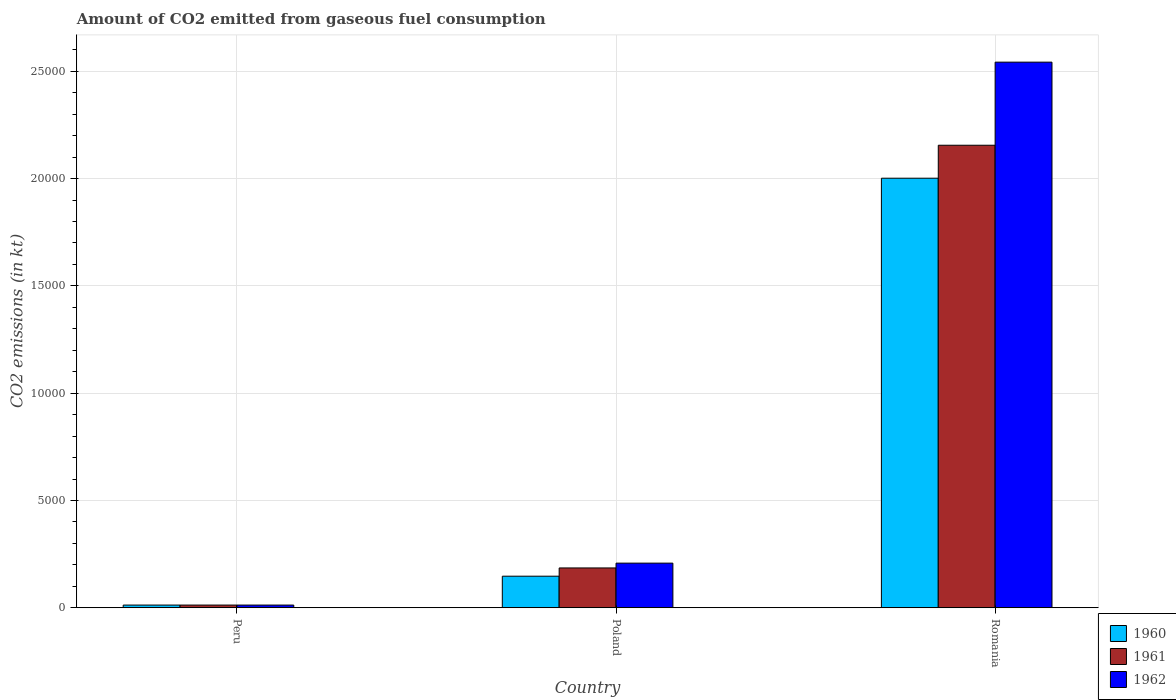How many groups of bars are there?
Make the answer very short. 3. Are the number of bars on each tick of the X-axis equal?
Give a very brief answer. Yes. How many bars are there on the 1st tick from the right?
Ensure brevity in your answer.  3. What is the label of the 2nd group of bars from the left?
Your response must be concise. Poland. What is the amount of CO2 emitted in 1960 in Poland?
Your answer should be compact. 1470.47. Across all countries, what is the maximum amount of CO2 emitted in 1961?
Your answer should be compact. 2.16e+04. Across all countries, what is the minimum amount of CO2 emitted in 1960?
Ensure brevity in your answer.  124.68. In which country was the amount of CO2 emitted in 1961 maximum?
Keep it short and to the point. Romania. What is the total amount of CO2 emitted in 1962 in the graph?
Offer a terse response. 2.76e+04. What is the difference between the amount of CO2 emitted in 1962 in Peru and that in Poland?
Ensure brevity in your answer.  -1954.51. What is the difference between the amount of CO2 emitted in 1961 in Poland and the amount of CO2 emitted in 1962 in Romania?
Ensure brevity in your answer.  -2.36e+04. What is the average amount of CO2 emitted in 1962 per country?
Your answer should be compact. 9210.28. What is the difference between the amount of CO2 emitted of/in 1960 and amount of CO2 emitted of/in 1962 in Poland?
Provide a succinct answer. -608.72. In how many countries, is the amount of CO2 emitted in 1960 greater than 22000 kt?
Provide a short and direct response. 0. What is the ratio of the amount of CO2 emitted in 1961 in Peru to that in Romania?
Ensure brevity in your answer.  0.01. Is the difference between the amount of CO2 emitted in 1960 in Peru and Poland greater than the difference between the amount of CO2 emitted in 1962 in Peru and Poland?
Keep it short and to the point. Yes. What is the difference between the highest and the second highest amount of CO2 emitted in 1960?
Provide a short and direct response. 1.99e+04. What is the difference between the highest and the lowest amount of CO2 emitted in 1960?
Ensure brevity in your answer.  1.99e+04. In how many countries, is the amount of CO2 emitted in 1960 greater than the average amount of CO2 emitted in 1960 taken over all countries?
Your answer should be compact. 1. What does the 1st bar from the left in Romania represents?
Offer a terse response. 1960. What does the 3rd bar from the right in Poland represents?
Provide a short and direct response. 1960. How many bars are there?
Your answer should be very brief. 9. How many countries are there in the graph?
Keep it short and to the point. 3. What is the difference between two consecutive major ticks on the Y-axis?
Your answer should be very brief. 5000. Are the values on the major ticks of Y-axis written in scientific E-notation?
Make the answer very short. No. Does the graph contain any zero values?
Keep it short and to the point. No. Does the graph contain grids?
Your answer should be compact. Yes. Where does the legend appear in the graph?
Your response must be concise. Bottom right. How many legend labels are there?
Provide a succinct answer. 3. What is the title of the graph?
Offer a very short reply. Amount of CO2 emitted from gaseous fuel consumption. Does "1975" appear as one of the legend labels in the graph?
Provide a succinct answer. No. What is the label or title of the Y-axis?
Keep it short and to the point. CO2 emissions (in kt). What is the CO2 emissions (in kt) of 1960 in Peru?
Ensure brevity in your answer.  124.68. What is the CO2 emissions (in kt) in 1961 in Peru?
Provide a succinct answer. 124.68. What is the CO2 emissions (in kt) of 1962 in Peru?
Provide a short and direct response. 124.68. What is the CO2 emissions (in kt) in 1960 in Poland?
Offer a terse response. 1470.47. What is the CO2 emissions (in kt) of 1961 in Poland?
Offer a terse response. 1855.5. What is the CO2 emissions (in kt) of 1962 in Poland?
Your answer should be very brief. 2079.19. What is the CO2 emissions (in kt) in 1960 in Romania?
Keep it short and to the point. 2.00e+04. What is the CO2 emissions (in kt) in 1961 in Romania?
Ensure brevity in your answer.  2.16e+04. What is the CO2 emissions (in kt) in 1962 in Romania?
Offer a terse response. 2.54e+04. Across all countries, what is the maximum CO2 emissions (in kt) in 1960?
Keep it short and to the point. 2.00e+04. Across all countries, what is the maximum CO2 emissions (in kt) in 1961?
Offer a very short reply. 2.16e+04. Across all countries, what is the maximum CO2 emissions (in kt) of 1962?
Provide a short and direct response. 2.54e+04. Across all countries, what is the minimum CO2 emissions (in kt) of 1960?
Keep it short and to the point. 124.68. Across all countries, what is the minimum CO2 emissions (in kt) of 1961?
Make the answer very short. 124.68. Across all countries, what is the minimum CO2 emissions (in kt) of 1962?
Offer a terse response. 124.68. What is the total CO2 emissions (in kt) in 1960 in the graph?
Offer a terse response. 2.16e+04. What is the total CO2 emissions (in kt) in 1961 in the graph?
Offer a very short reply. 2.35e+04. What is the total CO2 emissions (in kt) in 1962 in the graph?
Your answer should be very brief. 2.76e+04. What is the difference between the CO2 emissions (in kt) in 1960 in Peru and that in Poland?
Make the answer very short. -1345.79. What is the difference between the CO2 emissions (in kt) of 1961 in Peru and that in Poland?
Offer a terse response. -1730.82. What is the difference between the CO2 emissions (in kt) of 1962 in Peru and that in Poland?
Give a very brief answer. -1954.51. What is the difference between the CO2 emissions (in kt) in 1960 in Peru and that in Romania?
Ensure brevity in your answer.  -1.99e+04. What is the difference between the CO2 emissions (in kt) of 1961 in Peru and that in Romania?
Your response must be concise. -2.14e+04. What is the difference between the CO2 emissions (in kt) in 1962 in Peru and that in Romania?
Provide a short and direct response. -2.53e+04. What is the difference between the CO2 emissions (in kt) in 1960 in Poland and that in Romania?
Your response must be concise. -1.85e+04. What is the difference between the CO2 emissions (in kt) in 1961 in Poland and that in Romania?
Offer a terse response. -1.97e+04. What is the difference between the CO2 emissions (in kt) of 1962 in Poland and that in Romania?
Keep it short and to the point. -2.33e+04. What is the difference between the CO2 emissions (in kt) in 1960 in Peru and the CO2 emissions (in kt) in 1961 in Poland?
Offer a very short reply. -1730.82. What is the difference between the CO2 emissions (in kt) of 1960 in Peru and the CO2 emissions (in kt) of 1962 in Poland?
Your answer should be very brief. -1954.51. What is the difference between the CO2 emissions (in kt) in 1961 in Peru and the CO2 emissions (in kt) in 1962 in Poland?
Keep it short and to the point. -1954.51. What is the difference between the CO2 emissions (in kt) in 1960 in Peru and the CO2 emissions (in kt) in 1961 in Romania?
Give a very brief answer. -2.14e+04. What is the difference between the CO2 emissions (in kt) in 1960 in Peru and the CO2 emissions (in kt) in 1962 in Romania?
Ensure brevity in your answer.  -2.53e+04. What is the difference between the CO2 emissions (in kt) in 1961 in Peru and the CO2 emissions (in kt) in 1962 in Romania?
Provide a short and direct response. -2.53e+04. What is the difference between the CO2 emissions (in kt) in 1960 in Poland and the CO2 emissions (in kt) in 1961 in Romania?
Provide a succinct answer. -2.01e+04. What is the difference between the CO2 emissions (in kt) of 1960 in Poland and the CO2 emissions (in kt) of 1962 in Romania?
Your answer should be compact. -2.40e+04. What is the difference between the CO2 emissions (in kt) in 1961 in Poland and the CO2 emissions (in kt) in 1962 in Romania?
Offer a terse response. -2.36e+04. What is the average CO2 emissions (in kt) of 1960 per country?
Provide a short and direct response. 7204.43. What is the average CO2 emissions (in kt) of 1961 per country?
Your response must be concise. 7844.94. What is the average CO2 emissions (in kt) of 1962 per country?
Make the answer very short. 9210.28. What is the difference between the CO2 emissions (in kt) of 1960 and CO2 emissions (in kt) of 1961 in Peru?
Provide a short and direct response. 0. What is the difference between the CO2 emissions (in kt) in 1960 and CO2 emissions (in kt) in 1962 in Peru?
Your answer should be very brief. 0. What is the difference between the CO2 emissions (in kt) in 1960 and CO2 emissions (in kt) in 1961 in Poland?
Your answer should be very brief. -385.04. What is the difference between the CO2 emissions (in kt) in 1960 and CO2 emissions (in kt) in 1962 in Poland?
Give a very brief answer. -608.72. What is the difference between the CO2 emissions (in kt) in 1961 and CO2 emissions (in kt) in 1962 in Poland?
Offer a very short reply. -223.69. What is the difference between the CO2 emissions (in kt) in 1960 and CO2 emissions (in kt) in 1961 in Romania?
Your answer should be very brief. -1536.47. What is the difference between the CO2 emissions (in kt) of 1960 and CO2 emissions (in kt) of 1962 in Romania?
Your answer should be compact. -5408.82. What is the difference between the CO2 emissions (in kt) in 1961 and CO2 emissions (in kt) in 1962 in Romania?
Offer a very short reply. -3872.35. What is the ratio of the CO2 emissions (in kt) of 1960 in Peru to that in Poland?
Ensure brevity in your answer.  0.08. What is the ratio of the CO2 emissions (in kt) of 1961 in Peru to that in Poland?
Your answer should be compact. 0.07. What is the ratio of the CO2 emissions (in kt) of 1962 in Peru to that in Poland?
Keep it short and to the point. 0.06. What is the ratio of the CO2 emissions (in kt) of 1960 in Peru to that in Romania?
Ensure brevity in your answer.  0.01. What is the ratio of the CO2 emissions (in kt) in 1961 in Peru to that in Romania?
Your answer should be very brief. 0.01. What is the ratio of the CO2 emissions (in kt) of 1962 in Peru to that in Romania?
Your answer should be compact. 0. What is the ratio of the CO2 emissions (in kt) in 1960 in Poland to that in Romania?
Provide a succinct answer. 0.07. What is the ratio of the CO2 emissions (in kt) in 1961 in Poland to that in Romania?
Keep it short and to the point. 0.09. What is the ratio of the CO2 emissions (in kt) of 1962 in Poland to that in Romania?
Ensure brevity in your answer.  0.08. What is the difference between the highest and the second highest CO2 emissions (in kt) of 1960?
Make the answer very short. 1.85e+04. What is the difference between the highest and the second highest CO2 emissions (in kt) in 1961?
Make the answer very short. 1.97e+04. What is the difference between the highest and the second highest CO2 emissions (in kt) of 1962?
Offer a terse response. 2.33e+04. What is the difference between the highest and the lowest CO2 emissions (in kt) of 1960?
Provide a short and direct response. 1.99e+04. What is the difference between the highest and the lowest CO2 emissions (in kt) in 1961?
Ensure brevity in your answer.  2.14e+04. What is the difference between the highest and the lowest CO2 emissions (in kt) of 1962?
Ensure brevity in your answer.  2.53e+04. 